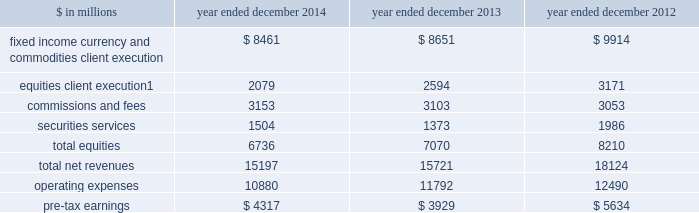Management 2019s discussion and analysis institutional client services our institutional client services segment is comprised of : fixed income , currency and commodities client execution .
Includes client execution activities related to making markets in interest rate products , credit products , mortgages , currencies and commodities .
2030 interest rate products .
Government bonds , money market instruments such as commercial paper , treasury bills , repurchase agreements and other highly liquid securities and instruments , as well as interest rate swaps , options and other derivatives .
2030 credit products .
Investment-grade corporate securities , high-yield securities , credit derivatives , bank and bridge loans , municipal securities , emerging market and distressed debt , and trade claims .
2030 mortgages .
Commercial mortgage-related securities , loans and derivatives , residential mortgage-related securities , loans and derivatives ( including u.s .
Government agency-issued collateralized mortgage obligations , other prime , subprime and alt-a securities and loans ) , and other asset-backed securities , loans and derivatives .
2030 currencies .
Most currencies , including growth-market currencies .
2030 commodities .
Crude oil and petroleum products , natural gas , base , precious and other metals , electricity , coal , agricultural and other commodity products .
Equities .
Includes client execution activities related to making markets in equity products and commissions and fees from executing and clearing institutional client transactions on major stock , options and futures exchanges worldwide , as well as otc transactions .
Equities also includes our securities services business , which provides financing , securities lending and other prime brokerage services to institutional clients , including hedge funds , mutual funds , pension funds and foundations , and generates revenues primarily in the form of interest rate spreads or fees .
The table below presents the operating results of our institutional client services segment. .
Net revenues related to the americas reinsurance business were $ 317 million for 2013 and $ 1.08 billion for 2012 .
In april 2013 , we completed the sale of a majority stake in our americas reinsurance business and no longer consolidate this business .
42 goldman sachs 2014 annual report .
In millions for 2014 , 2013 , and 2012 , what was the minimum amount of commissions and fees? 
Computations: table_min(commissions and fees, none)
Answer: 3053.0. 